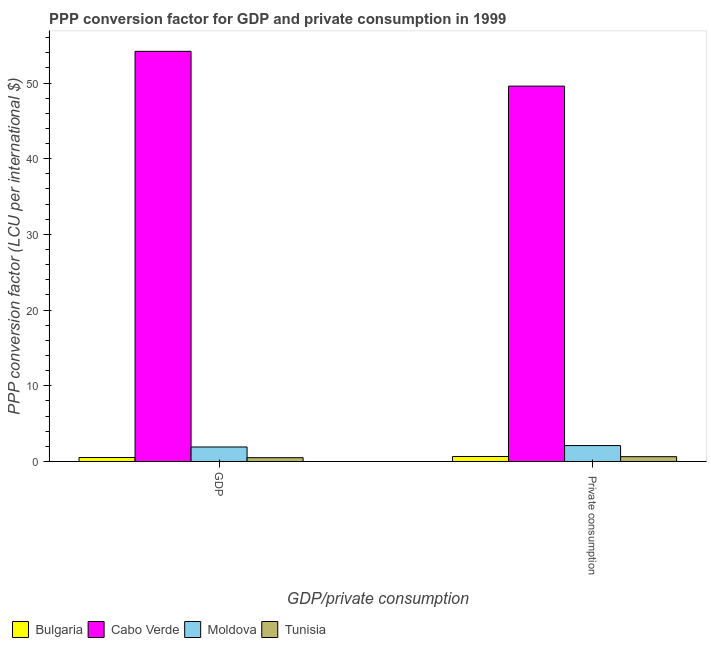Are the number of bars per tick equal to the number of legend labels?
Your answer should be very brief. Yes. Are the number of bars on each tick of the X-axis equal?
Your response must be concise. Yes. How many bars are there on the 1st tick from the right?
Offer a very short reply. 4. What is the label of the 1st group of bars from the left?
Your response must be concise. GDP. What is the ppp conversion factor for gdp in Tunisia?
Give a very brief answer. 0.5. Across all countries, what is the maximum ppp conversion factor for gdp?
Your response must be concise. 54.19. Across all countries, what is the minimum ppp conversion factor for private consumption?
Provide a succinct answer. 0.63. In which country was the ppp conversion factor for private consumption maximum?
Provide a succinct answer. Cabo Verde. In which country was the ppp conversion factor for gdp minimum?
Your answer should be very brief. Tunisia. What is the total ppp conversion factor for private consumption in the graph?
Provide a short and direct response. 52.98. What is the difference between the ppp conversion factor for gdp in Bulgaria and that in Tunisia?
Your answer should be very brief. 0.02. What is the difference between the ppp conversion factor for private consumption in Bulgaria and the ppp conversion factor for gdp in Cabo Verde?
Your answer should be very brief. -53.53. What is the average ppp conversion factor for private consumption per country?
Keep it short and to the point. 13.25. What is the difference between the ppp conversion factor for private consumption and ppp conversion factor for gdp in Bulgaria?
Provide a succinct answer. 0.14. What is the ratio of the ppp conversion factor for private consumption in Cabo Verde to that in Bulgaria?
Offer a terse response. 75.35. Is the ppp conversion factor for gdp in Bulgaria less than that in Tunisia?
Your response must be concise. No. In how many countries, is the ppp conversion factor for private consumption greater than the average ppp conversion factor for private consumption taken over all countries?
Your answer should be very brief. 1. What does the 1st bar from the left in GDP represents?
Your answer should be very brief. Bulgaria. What does the 4th bar from the right in  Private consumption represents?
Offer a terse response. Bulgaria. How many bars are there?
Offer a very short reply. 8. Are all the bars in the graph horizontal?
Keep it short and to the point. No. What is the difference between two consecutive major ticks on the Y-axis?
Make the answer very short. 10. Are the values on the major ticks of Y-axis written in scientific E-notation?
Make the answer very short. No. Does the graph contain any zero values?
Ensure brevity in your answer.  No. Does the graph contain grids?
Make the answer very short. No. Where does the legend appear in the graph?
Your response must be concise. Bottom left. How many legend labels are there?
Your response must be concise. 4. How are the legend labels stacked?
Provide a short and direct response. Horizontal. What is the title of the graph?
Your answer should be very brief. PPP conversion factor for GDP and private consumption in 1999. What is the label or title of the X-axis?
Offer a terse response. GDP/private consumption. What is the label or title of the Y-axis?
Make the answer very short. PPP conversion factor (LCU per international $). What is the PPP conversion factor (LCU per international $) in Bulgaria in GDP?
Give a very brief answer. 0.52. What is the PPP conversion factor (LCU per international $) of Cabo Verde in GDP?
Your answer should be very brief. 54.19. What is the PPP conversion factor (LCU per international $) of Moldova in GDP?
Provide a succinct answer. 1.92. What is the PPP conversion factor (LCU per international $) of Tunisia in GDP?
Your response must be concise. 0.5. What is the PPP conversion factor (LCU per international $) of Bulgaria in  Private consumption?
Give a very brief answer. 0.66. What is the PPP conversion factor (LCU per international $) of Cabo Verde in  Private consumption?
Make the answer very short. 49.59. What is the PPP conversion factor (LCU per international $) of Moldova in  Private consumption?
Make the answer very short. 2.1. What is the PPP conversion factor (LCU per international $) of Tunisia in  Private consumption?
Your answer should be compact. 0.63. Across all GDP/private consumption, what is the maximum PPP conversion factor (LCU per international $) in Bulgaria?
Offer a terse response. 0.66. Across all GDP/private consumption, what is the maximum PPP conversion factor (LCU per international $) of Cabo Verde?
Ensure brevity in your answer.  54.19. Across all GDP/private consumption, what is the maximum PPP conversion factor (LCU per international $) of Moldova?
Ensure brevity in your answer.  2.1. Across all GDP/private consumption, what is the maximum PPP conversion factor (LCU per international $) of Tunisia?
Offer a terse response. 0.63. Across all GDP/private consumption, what is the minimum PPP conversion factor (LCU per international $) in Bulgaria?
Make the answer very short. 0.52. Across all GDP/private consumption, what is the minimum PPP conversion factor (LCU per international $) of Cabo Verde?
Give a very brief answer. 49.59. Across all GDP/private consumption, what is the minimum PPP conversion factor (LCU per international $) of Moldova?
Offer a terse response. 1.92. Across all GDP/private consumption, what is the minimum PPP conversion factor (LCU per international $) of Tunisia?
Keep it short and to the point. 0.5. What is the total PPP conversion factor (LCU per international $) of Bulgaria in the graph?
Give a very brief answer. 1.18. What is the total PPP conversion factor (LCU per international $) in Cabo Verde in the graph?
Keep it short and to the point. 103.78. What is the total PPP conversion factor (LCU per international $) in Moldova in the graph?
Provide a succinct answer. 4.02. What is the total PPP conversion factor (LCU per international $) in Tunisia in the graph?
Provide a succinct answer. 1.13. What is the difference between the PPP conversion factor (LCU per international $) of Bulgaria in GDP and that in  Private consumption?
Your response must be concise. -0.14. What is the difference between the PPP conversion factor (LCU per international $) of Cabo Verde in GDP and that in  Private consumption?
Give a very brief answer. 4.6. What is the difference between the PPP conversion factor (LCU per international $) in Moldova in GDP and that in  Private consumption?
Ensure brevity in your answer.  -0.19. What is the difference between the PPP conversion factor (LCU per international $) of Tunisia in GDP and that in  Private consumption?
Keep it short and to the point. -0.13. What is the difference between the PPP conversion factor (LCU per international $) in Bulgaria in GDP and the PPP conversion factor (LCU per international $) in Cabo Verde in  Private consumption?
Provide a short and direct response. -49.07. What is the difference between the PPP conversion factor (LCU per international $) of Bulgaria in GDP and the PPP conversion factor (LCU per international $) of Moldova in  Private consumption?
Offer a terse response. -1.58. What is the difference between the PPP conversion factor (LCU per international $) of Bulgaria in GDP and the PPP conversion factor (LCU per international $) of Tunisia in  Private consumption?
Make the answer very short. -0.11. What is the difference between the PPP conversion factor (LCU per international $) of Cabo Verde in GDP and the PPP conversion factor (LCU per international $) of Moldova in  Private consumption?
Offer a terse response. 52.09. What is the difference between the PPP conversion factor (LCU per international $) of Cabo Verde in GDP and the PPP conversion factor (LCU per international $) of Tunisia in  Private consumption?
Provide a succinct answer. 53.56. What is the difference between the PPP conversion factor (LCU per international $) of Moldova in GDP and the PPP conversion factor (LCU per international $) of Tunisia in  Private consumption?
Offer a terse response. 1.28. What is the average PPP conversion factor (LCU per international $) of Bulgaria per GDP/private consumption?
Keep it short and to the point. 0.59. What is the average PPP conversion factor (LCU per international $) of Cabo Verde per GDP/private consumption?
Provide a succinct answer. 51.89. What is the average PPP conversion factor (LCU per international $) in Moldova per GDP/private consumption?
Offer a terse response. 2.01. What is the average PPP conversion factor (LCU per international $) in Tunisia per GDP/private consumption?
Provide a succinct answer. 0.57. What is the difference between the PPP conversion factor (LCU per international $) of Bulgaria and PPP conversion factor (LCU per international $) of Cabo Verde in GDP?
Your response must be concise. -53.67. What is the difference between the PPP conversion factor (LCU per international $) in Bulgaria and PPP conversion factor (LCU per international $) in Moldova in GDP?
Offer a very short reply. -1.39. What is the difference between the PPP conversion factor (LCU per international $) of Bulgaria and PPP conversion factor (LCU per international $) of Tunisia in GDP?
Offer a very short reply. 0.02. What is the difference between the PPP conversion factor (LCU per international $) of Cabo Verde and PPP conversion factor (LCU per international $) of Moldova in GDP?
Keep it short and to the point. 52.27. What is the difference between the PPP conversion factor (LCU per international $) in Cabo Verde and PPP conversion factor (LCU per international $) in Tunisia in GDP?
Provide a short and direct response. 53.69. What is the difference between the PPP conversion factor (LCU per international $) of Moldova and PPP conversion factor (LCU per international $) of Tunisia in GDP?
Give a very brief answer. 1.42. What is the difference between the PPP conversion factor (LCU per international $) of Bulgaria and PPP conversion factor (LCU per international $) of Cabo Verde in  Private consumption?
Ensure brevity in your answer.  -48.93. What is the difference between the PPP conversion factor (LCU per international $) of Bulgaria and PPP conversion factor (LCU per international $) of Moldova in  Private consumption?
Ensure brevity in your answer.  -1.44. What is the difference between the PPP conversion factor (LCU per international $) of Bulgaria and PPP conversion factor (LCU per international $) of Tunisia in  Private consumption?
Offer a terse response. 0.03. What is the difference between the PPP conversion factor (LCU per international $) of Cabo Verde and PPP conversion factor (LCU per international $) of Moldova in  Private consumption?
Keep it short and to the point. 47.49. What is the difference between the PPP conversion factor (LCU per international $) of Cabo Verde and PPP conversion factor (LCU per international $) of Tunisia in  Private consumption?
Provide a short and direct response. 48.96. What is the difference between the PPP conversion factor (LCU per international $) of Moldova and PPP conversion factor (LCU per international $) of Tunisia in  Private consumption?
Offer a terse response. 1.47. What is the ratio of the PPP conversion factor (LCU per international $) in Bulgaria in GDP to that in  Private consumption?
Keep it short and to the point. 0.79. What is the ratio of the PPP conversion factor (LCU per international $) of Cabo Verde in GDP to that in  Private consumption?
Make the answer very short. 1.09. What is the ratio of the PPP conversion factor (LCU per international $) in Moldova in GDP to that in  Private consumption?
Your answer should be compact. 0.91. What is the ratio of the PPP conversion factor (LCU per international $) of Tunisia in GDP to that in  Private consumption?
Give a very brief answer. 0.79. What is the difference between the highest and the second highest PPP conversion factor (LCU per international $) in Bulgaria?
Your answer should be very brief. 0.14. What is the difference between the highest and the second highest PPP conversion factor (LCU per international $) in Cabo Verde?
Ensure brevity in your answer.  4.6. What is the difference between the highest and the second highest PPP conversion factor (LCU per international $) of Moldova?
Make the answer very short. 0.19. What is the difference between the highest and the second highest PPP conversion factor (LCU per international $) of Tunisia?
Provide a short and direct response. 0.13. What is the difference between the highest and the lowest PPP conversion factor (LCU per international $) of Bulgaria?
Make the answer very short. 0.14. What is the difference between the highest and the lowest PPP conversion factor (LCU per international $) in Cabo Verde?
Keep it short and to the point. 4.6. What is the difference between the highest and the lowest PPP conversion factor (LCU per international $) in Moldova?
Your answer should be very brief. 0.19. What is the difference between the highest and the lowest PPP conversion factor (LCU per international $) in Tunisia?
Keep it short and to the point. 0.13. 